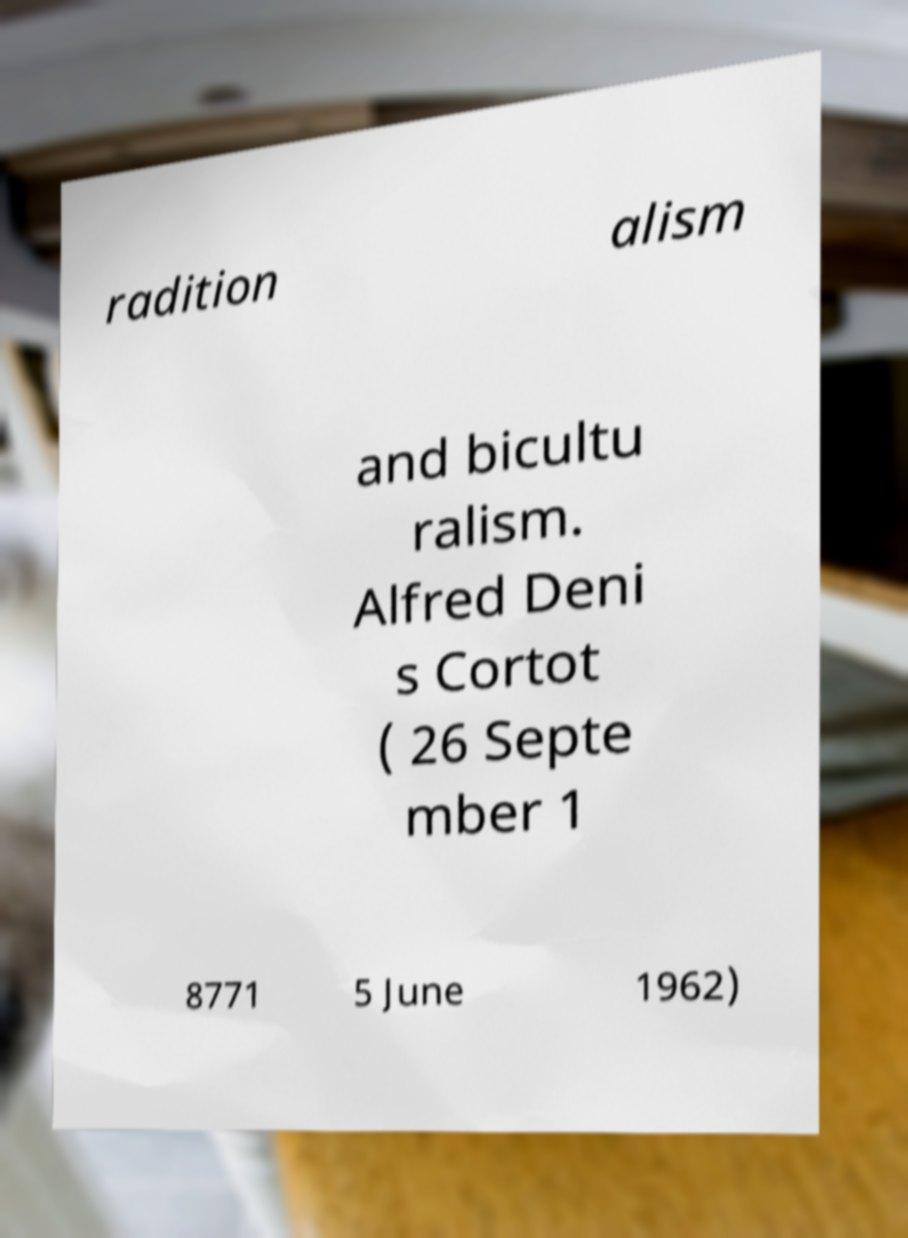Please identify and transcribe the text found in this image. radition alism and bicultu ralism. Alfred Deni s Cortot ( 26 Septe mber 1 8771 5 June 1962) 